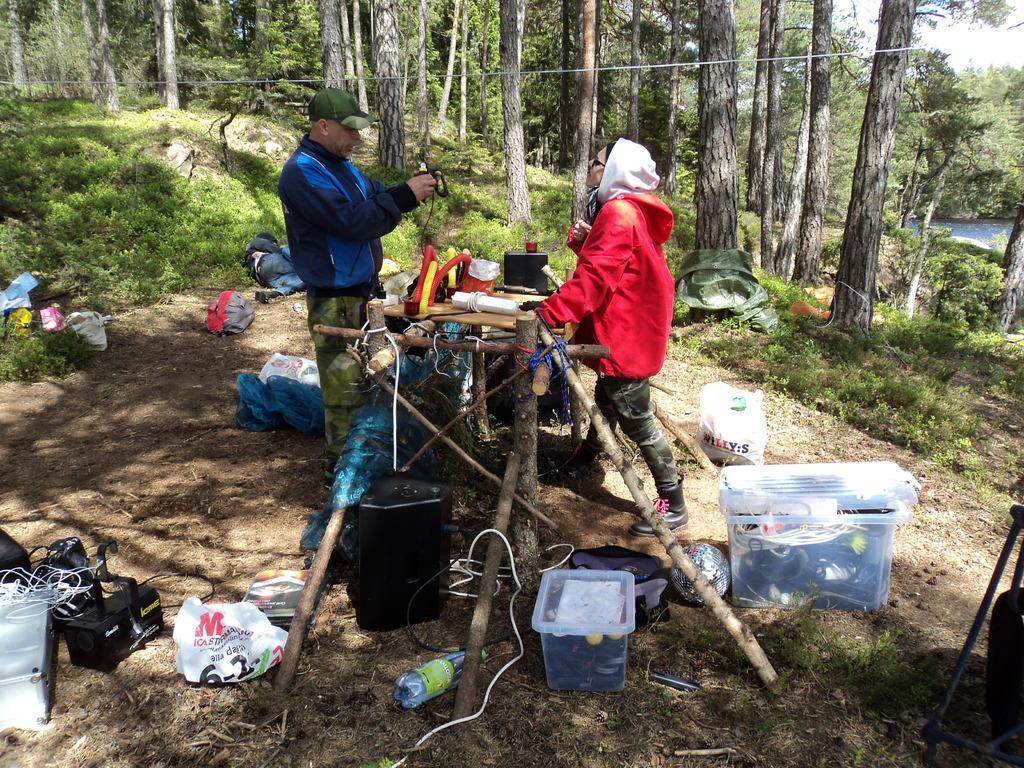Please provide a concise description of this image. In the background we can see tree trunks, leaves. In this picture we can see plants. We can see a man and a woman standing. On a table we can see few objects. We can see a man is holding an object. We can see objects and bags on the ground. We can see a person is lying on the ground. 